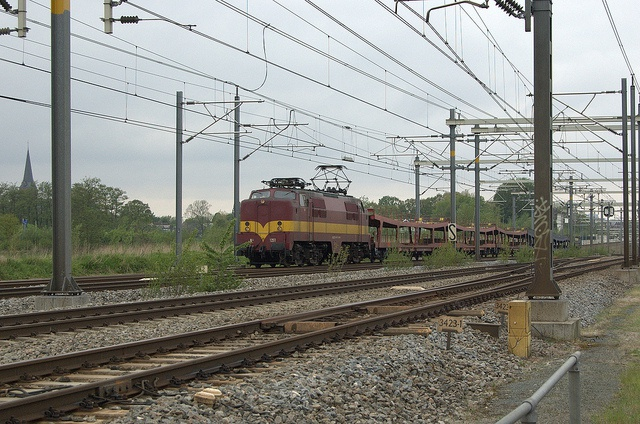Describe the objects in this image and their specific colors. I can see a train in black, gray, and maroon tones in this image. 